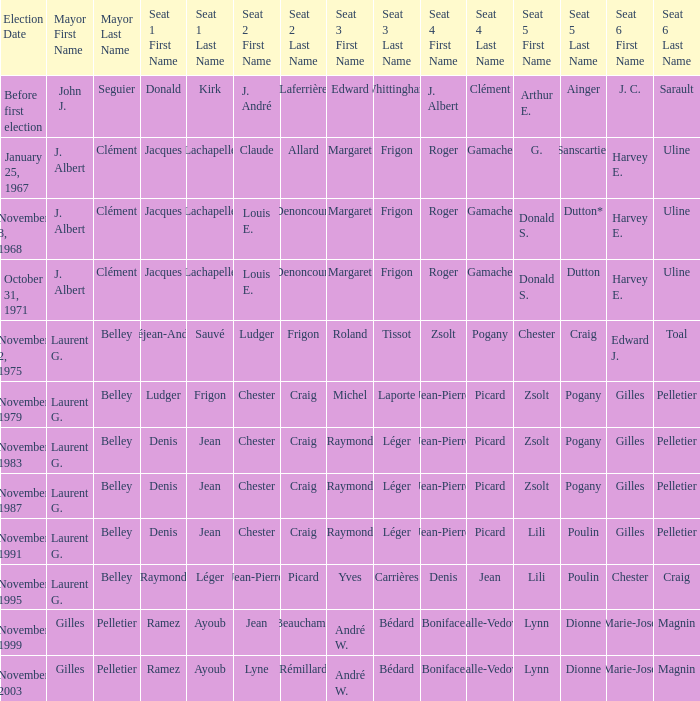Who is seat no 1 when the mayor was john j. seguier Donald Kirk. 